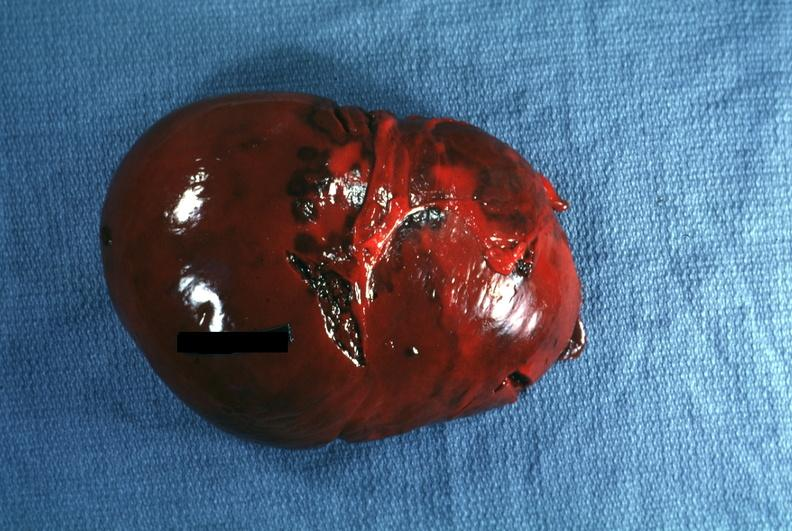what does this image show?
Answer the question using a single word or phrase. External view several capsule lacerations easily seen 